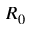Convert formula to latex. <formula><loc_0><loc_0><loc_500><loc_500>R _ { 0 }</formula> 